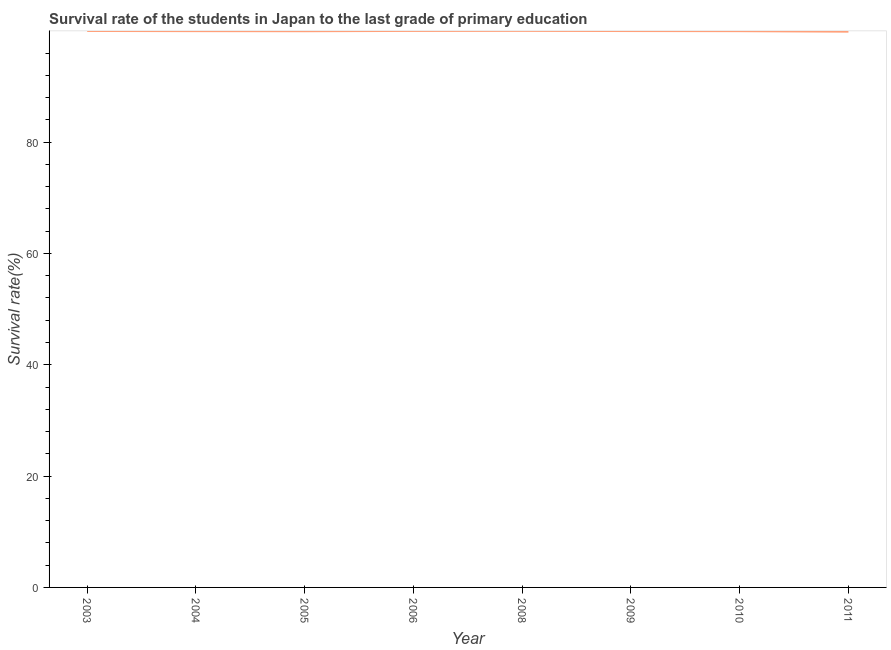What is the survival rate in primary education in 2003?
Your answer should be compact. 99.97. Across all years, what is the maximum survival rate in primary education?
Ensure brevity in your answer.  99.98. Across all years, what is the minimum survival rate in primary education?
Offer a very short reply. 99.84. In which year was the survival rate in primary education maximum?
Offer a terse response. 2008. What is the sum of the survival rate in primary education?
Ensure brevity in your answer.  799.5. What is the difference between the survival rate in primary education in 2003 and 2005?
Make the answer very short. 0.05. What is the average survival rate in primary education per year?
Your answer should be compact. 99.94. What is the median survival rate in primary education?
Provide a short and direct response. 99.94. In how many years, is the survival rate in primary education greater than 48 %?
Provide a short and direct response. 8. Do a majority of the years between 2010 and 2008 (inclusive) have survival rate in primary education greater than 92 %?
Make the answer very short. No. What is the ratio of the survival rate in primary education in 2006 to that in 2010?
Provide a succinct answer. 1. Is the survival rate in primary education in 2004 less than that in 2010?
Provide a short and direct response. No. What is the difference between the highest and the second highest survival rate in primary education?
Offer a very short reply. 0.01. What is the difference between the highest and the lowest survival rate in primary education?
Give a very brief answer. 0.15. In how many years, is the survival rate in primary education greater than the average survival rate in primary education taken over all years?
Keep it short and to the point. 4. How many lines are there?
Offer a very short reply. 1. How many years are there in the graph?
Provide a short and direct response. 8. What is the difference between two consecutive major ticks on the Y-axis?
Keep it short and to the point. 20. Are the values on the major ticks of Y-axis written in scientific E-notation?
Your answer should be very brief. No. Does the graph contain any zero values?
Ensure brevity in your answer.  No. Does the graph contain grids?
Ensure brevity in your answer.  No. What is the title of the graph?
Keep it short and to the point. Survival rate of the students in Japan to the last grade of primary education. What is the label or title of the Y-axis?
Keep it short and to the point. Survival rate(%). What is the Survival rate(%) of 2003?
Provide a succinct answer. 99.97. What is the Survival rate(%) of 2004?
Keep it short and to the point. 99.93. What is the Survival rate(%) of 2005?
Provide a short and direct response. 99.92. What is the Survival rate(%) in 2006?
Give a very brief answer. 99.97. What is the Survival rate(%) in 2008?
Offer a terse response. 99.98. What is the Survival rate(%) in 2009?
Make the answer very short. 99.95. What is the Survival rate(%) of 2010?
Ensure brevity in your answer.  99.93. What is the Survival rate(%) in 2011?
Your answer should be very brief. 99.84. What is the difference between the Survival rate(%) in 2003 and 2004?
Keep it short and to the point. 0.03. What is the difference between the Survival rate(%) in 2003 and 2005?
Your answer should be compact. 0.05. What is the difference between the Survival rate(%) in 2003 and 2006?
Give a very brief answer. -0.01. What is the difference between the Survival rate(%) in 2003 and 2008?
Give a very brief answer. -0.02. What is the difference between the Survival rate(%) in 2003 and 2009?
Ensure brevity in your answer.  0.01. What is the difference between the Survival rate(%) in 2003 and 2010?
Your response must be concise. 0.04. What is the difference between the Survival rate(%) in 2003 and 2011?
Your answer should be very brief. 0.13. What is the difference between the Survival rate(%) in 2004 and 2005?
Provide a short and direct response. 0.01. What is the difference between the Survival rate(%) in 2004 and 2006?
Your response must be concise. -0.04. What is the difference between the Survival rate(%) in 2004 and 2008?
Ensure brevity in your answer.  -0.05. What is the difference between the Survival rate(%) in 2004 and 2009?
Keep it short and to the point. -0.02. What is the difference between the Survival rate(%) in 2004 and 2010?
Your answer should be very brief. 0. What is the difference between the Survival rate(%) in 2004 and 2011?
Ensure brevity in your answer.  0.1. What is the difference between the Survival rate(%) in 2005 and 2006?
Provide a short and direct response. -0.05. What is the difference between the Survival rate(%) in 2005 and 2008?
Provide a short and direct response. -0.06. What is the difference between the Survival rate(%) in 2005 and 2009?
Offer a very short reply. -0.03. What is the difference between the Survival rate(%) in 2005 and 2010?
Give a very brief answer. -0.01. What is the difference between the Survival rate(%) in 2005 and 2011?
Provide a short and direct response. 0.08. What is the difference between the Survival rate(%) in 2006 and 2008?
Offer a terse response. -0.01. What is the difference between the Survival rate(%) in 2006 and 2009?
Provide a succinct answer. 0.02. What is the difference between the Survival rate(%) in 2006 and 2010?
Ensure brevity in your answer.  0.04. What is the difference between the Survival rate(%) in 2006 and 2011?
Provide a succinct answer. 0.13. What is the difference between the Survival rate(%) in 2008 and 2009?
Your response must be concise. 0.03. What is the difference between the Survival rate(%) in 2008 and 2010?
Offer a very short reply. 0.05. What is the difference between the Survival rate(%) in 2008 and 2011?
Ensure brevity in your answer.  0.15. What is the difference between the Survival rate(%) in 2009 and 2010?
Your answer should be compact. 0.02. What is the difference between the Survival rate(%) in 2009 and 2011?
Offer a very short reply. 0.11. What is the difference between the Survival rate(%) in 2010 and 2011?
Your answer should be compact. 0.09. What is the ratio of the Survival rate(%) in 2003 to that in 2004?
Offer a very short reply. 1. What is the ratio of the Survival rate(%) in 2003 to that in 2005?
Offer a terse response. 1. What is the ratio of the Survival rate(%) in 2004 to that in 2005?
Give a very brief answer. 1. What is the ratio of the Survival rate(%) in 2004 to that in 2006?
Offer a very short reply. 1. What is the ratio of the Survival rate(%) in 2004 to that in 2008?
Provide a short and direct response. 1. What is the ratio of the Survival rate(%) in 2004 to that in 2009?
Give a very brief answer. 1. What is the ratio of the Survival rate(%) in 2004 to that in 2010?
Keep it short and to the point. 1. What is the ratio of the Survival rate(%) in 2004 to that in 2011?
Provide a short and direct response. 1. What is the ratio of the Survival rate(%) in 2005 to that in 2011?
Provide a succinct answer. 1. What is the ratio of the Survival rate(%) in 2006 to that in 2011?
Give a very brief answer. 1. What is the ratio of the Survival rate(%) in 2008 to that in 2010?
Make the answer very short. 1. What is the ratio of the Survival rate(%) in 2008 to that in 2011?
Make the answer very short. 1. What is the ratio of the Survival rate(%) in 2009 to that in 2010?
Keep it short and to the point. 1. What is the ratio of the Survival rate(%) in 2009 to that in 2011?
Provide a succinct answer. 1. What is the ratio of the Survival rate(%) in 2010 to that in 2011?
Your answer should be very brief. 1. 